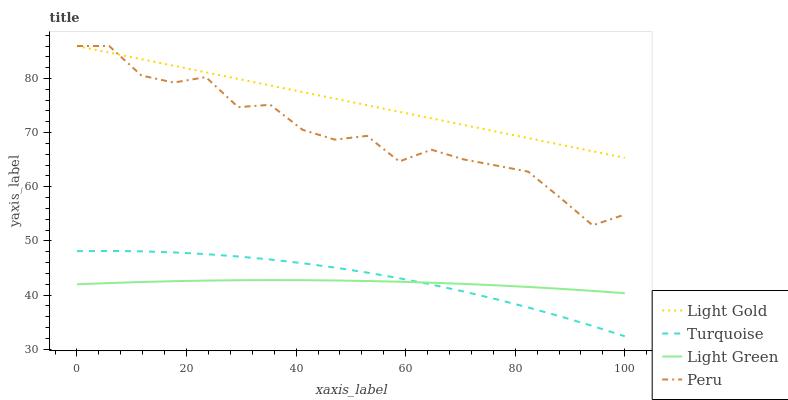Does Peru have the minimum area under the curve?
Answer yes or no. No. Does Peru have the maximum area under the curve?
Answer yes or no. No. Is Peru the smoothest?
Answer yes or no. No. Is Light Gold the roughest?
Answer yes or no. No. Does Peru have the lowest value?
Answer yes or no. No. Does Light Green have the highest value?
Answer yes or no. No. Is Light Green less than Peru?
Answer yes or no. Yes. Is Light Gold greater than Light Green?
Answer yes or no. Yes. Does Light Green intersect Peru?
Answer yes or no. No. 